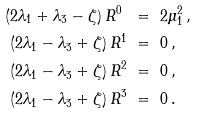Convert formula to latex. <formula><loc_0><loc_0><loc_500><loc_500>( 2 \lambda _ { 1 } + \lambda _ { 3 } - \zeta ) \, R ^ { 0 } \ & = \ 2 \mu _ { 1 } ^ { 2 } \, , \\ ( 2 \lambda _ { 1 } - \lambda _ { 3 } + \zeta ) \, R ^ { 1 } \ & = \ 0 \, , \\ ( 2 \lambda _ { 1 } - \lambda _ { 3 } + \zeta ) \, R ^ { 2 } \ & = \ 0 \, , \\ ( 2 \lambda _ { 1 } - \lambda _ { 3 } + \zeta ) \, R ^ { 3 } \ & = \ 0 \, .</formula> 